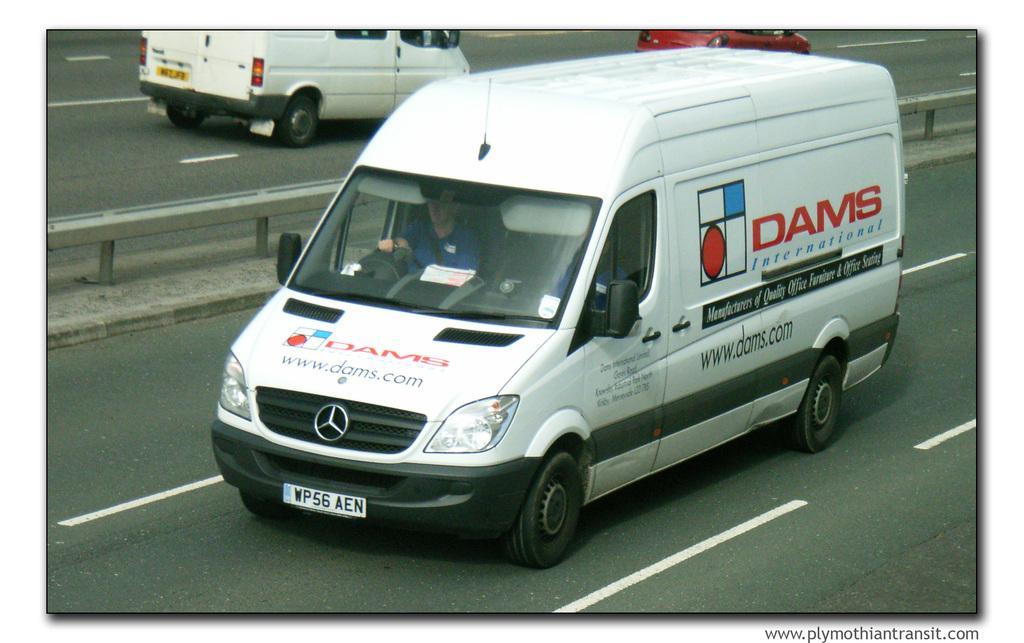How would you summarize this image in a sentence or two? There are roads. On the roads there are vehicles. Inside the vehicle there is a person. On the vehicle there is something written. Also there are logos. Between the words there is railing. In the right bottom corner there is a watermark. 